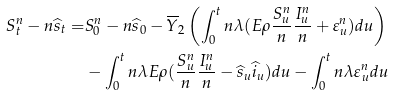Convert formula to latex. <formula><loc_0><loc_0><loc_500><loc_500>S _ { t } ^ { n } - n \widehat { s } _ { t } = & S _ { 0 } ^ { n } - n \widehat { s } _ { 0 } - \overline { Y } _ { 2 } \left ( \int _ { 0 } ^ { t } n \lambda ( E \rho \frac { S _ { u } ^ { n } } { n } \frac { I _ { u } ^ { n } } { n } + \varepsilon _ { u } ^ { n } ) d u \right ) \\ & - \int _ { 0 } ^ { t } n \lambda E \rho ( \frac { S ^ { n } _ { u } } { n } \frac { I ^ { n } _ { u } } { n } - \widehat { s } _ { u } \widehat { i } _ { u } ) d u - \int _ { 0 } ^ { t } n \lambda \varepsilon _ { u } ^ { n } d u</formula> 